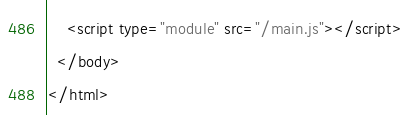Convert code to text. <code><loc_0><loc_0><loc_500><loc_500><_HTML_>    <script type="module" src="/main.js"></script>
  </body>
</html>
</code> 